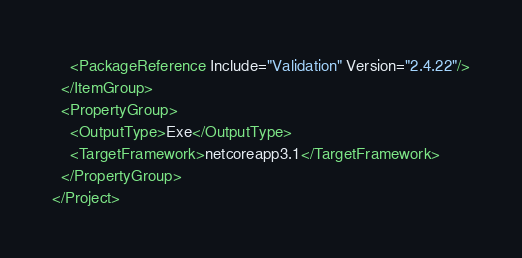<code> <loc_0><loc_0><loc_500><loc_500><_XML_>    <PackageReference Include="Validation" Version="2.4.22"/>
  </ItemGroup>
  <PropertyGroup>
    <OutputType>Exe</OutputType>
    <TargetFramework>netcoreapp3.1</TargetFramework>
  </PropertyGroup>
</Project></code> 